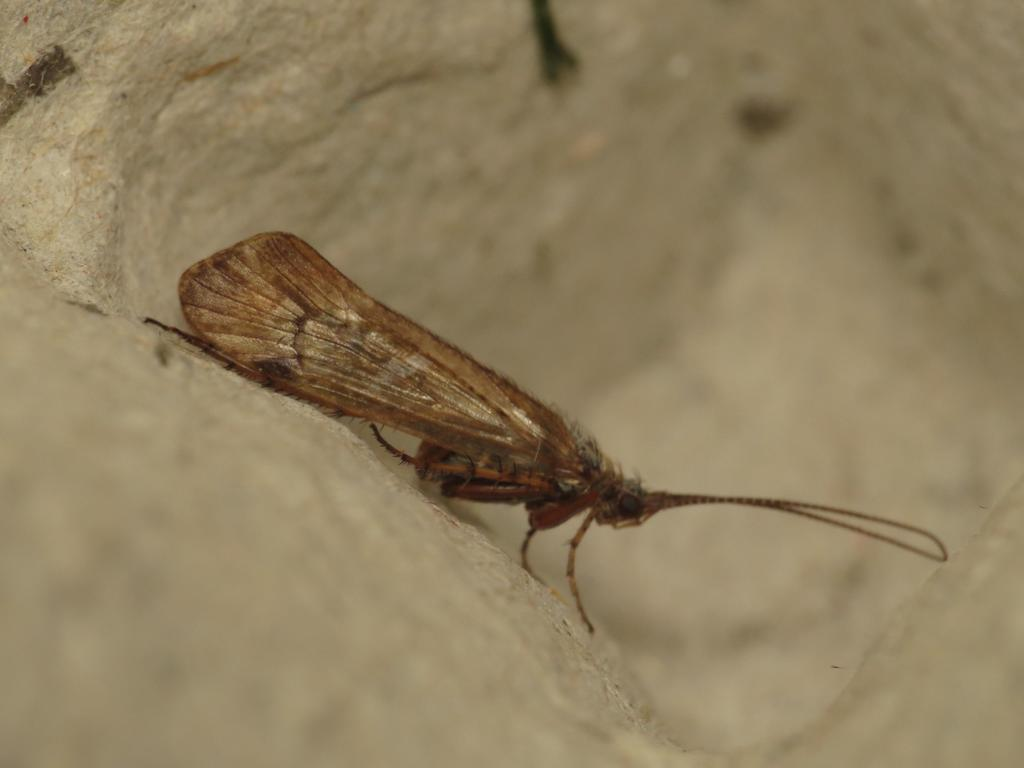What type of creature is present in the image? There is an insect in the image. What color is the insect? The insect is brown in color. What is the background or surface that the insect is on? The insect is on a cream and white color surface. What time does the clock show in the image? There is no clock present in the image, so it is not possible to determine the time. 